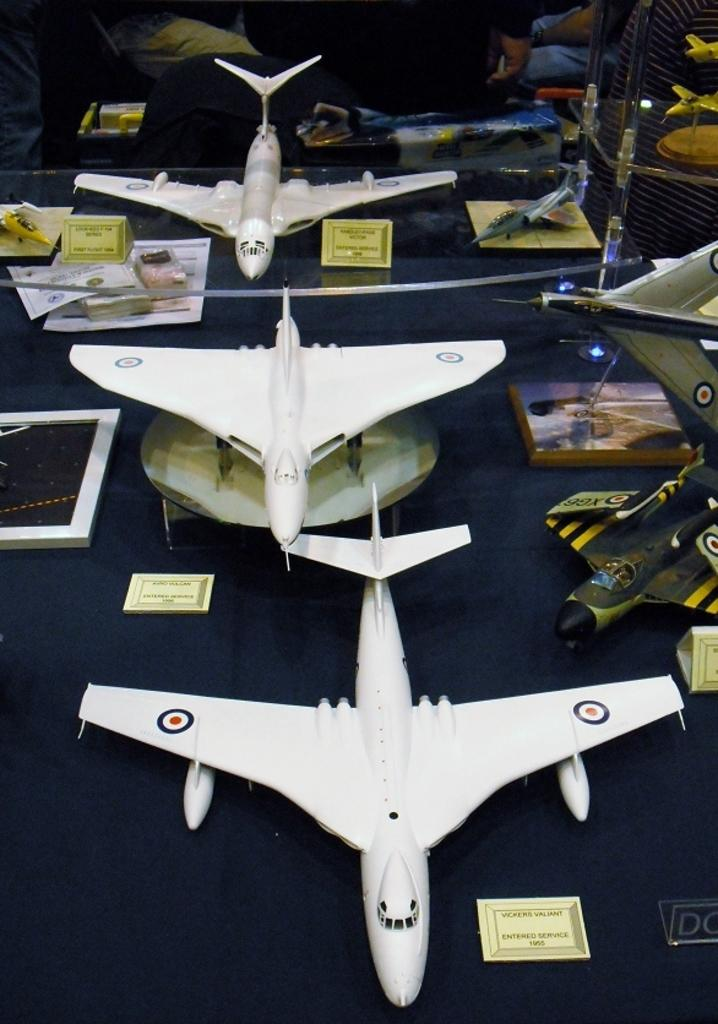What is the main subject of the image? The main subject of the image is aircrafts. What else can be seen in the image besides the aircrafts? There are boards on a table and people in the background of the image. What type of brain can be seen in the image? There is no brain present in the image; it features aircrafts, boards on a table, and people in the background. 